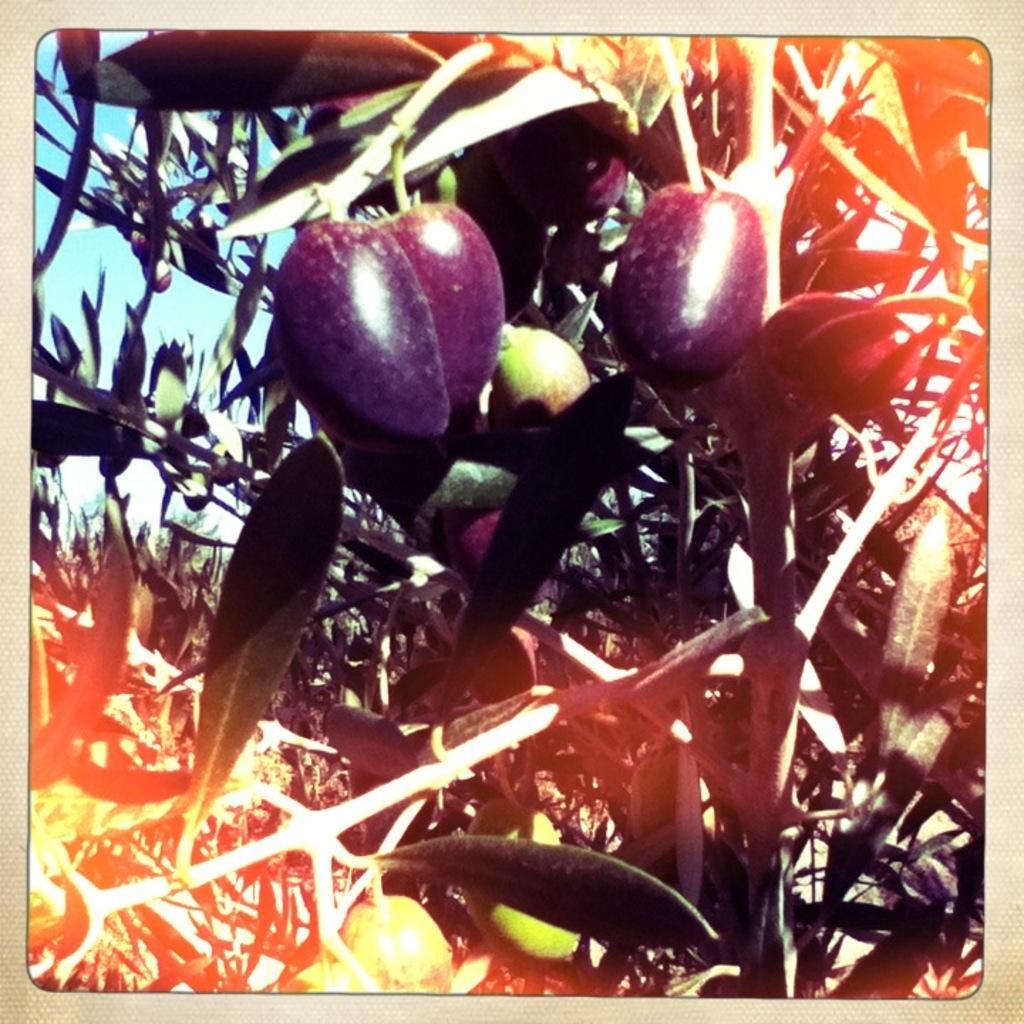Please provide a concise description of this image. In this image we can see aubergines on the aubergine plant. 